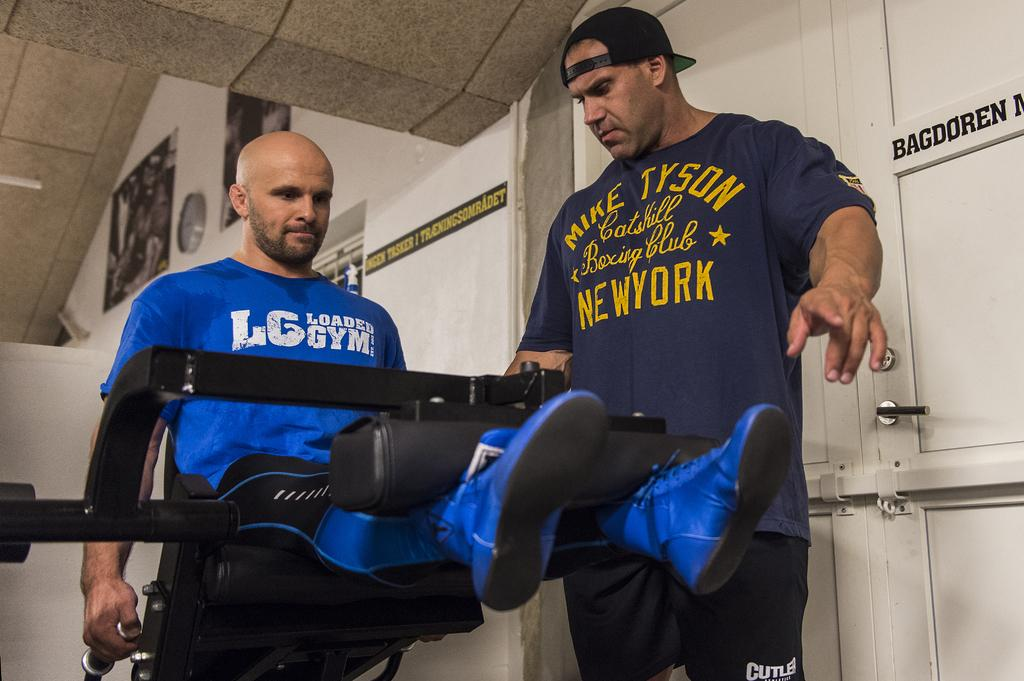<image>
Render a clear and concise summary of the photo. A man coaches another man who is wearing a Loaded Gym shirt. 